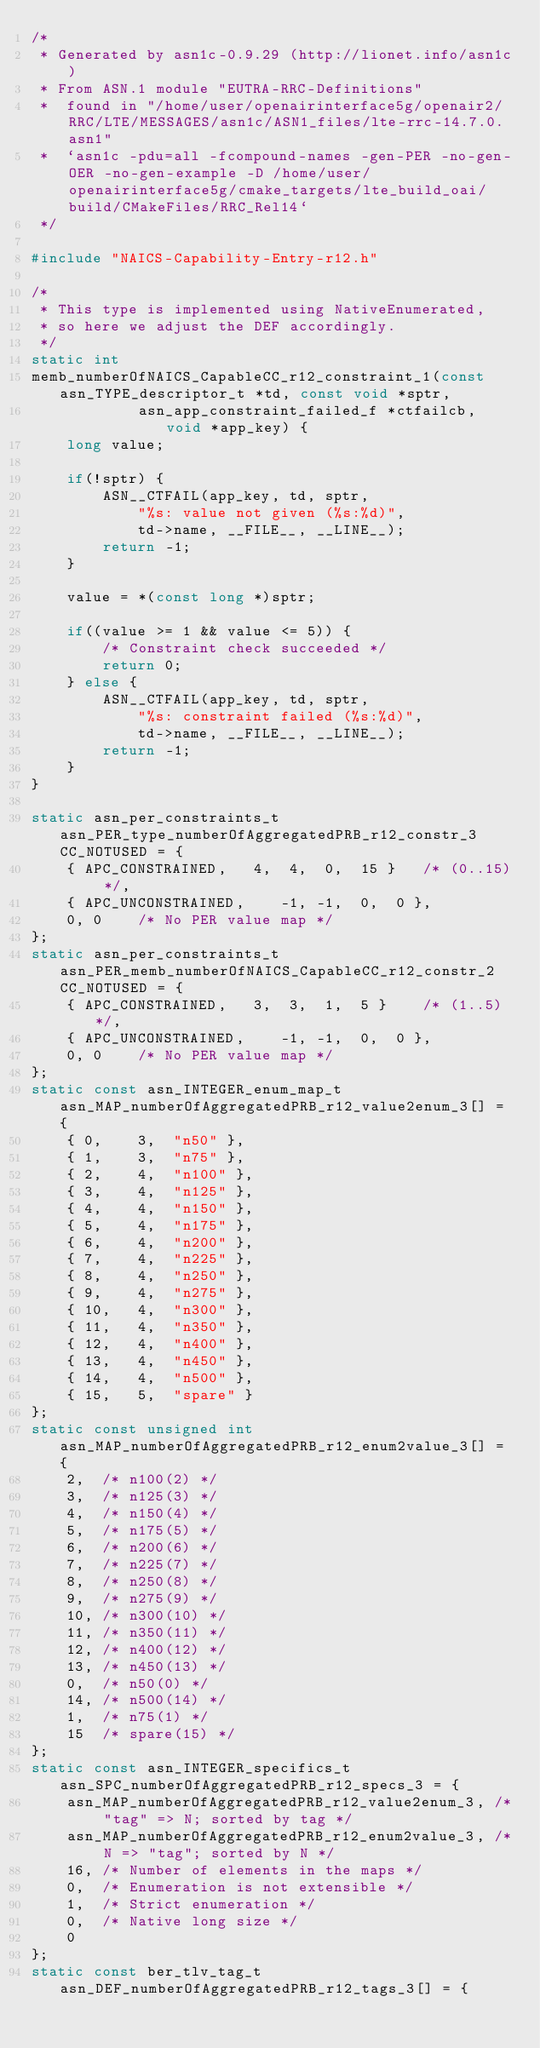<code> <loc_0><loc_0><loc_500><loc_500><_C_>/*
 * Generated by asn1c-0.9.29 (http://lionet.info/asn1c)
 * From ASN.1 module "EUTRA-RRC-Definitions"
 * 	found in "/home/user/openairinterface5g/openair2/RRC/LTE/MESSAGES/asn1c/ASN1_files/lte-rrc-14.7.0.asn1"
 * 	`asn1c -pdu=all -fcompound-names -gen-PER -no-gen-OER -no-gen-example -D /home/user/openairinterface5g/cmake_targets/lte_build_oai/build/CMakeFiles/RRC_Rel14`
 */

#include "NAICS-Capability-Entry-r12.h"

/*
 * This type is implemented using NativeEnumerated,
 * so here we adjust the DEF accordingly.
 */
static int
memb_numberOfNAICS_CapableCC_r12_constraint_1(const asn_TYPE_descriptor_t *td, const void *sptr,
			asn_app_constraint_failed_f *ctfailcb, void *app_key) {
	long value;
	
	if(!sptr) {
		ASN__CTFAIL(app_key, td, sptr,
			"%s: value not given (%s:%d)",
			td->name, __FILE__, __LINE__);
		return -1;
	}
	
	value = *(const long *)sptr;
	
	if((value >= 1 && value <= 5)) {
		/* Constraint check succeeded */
		return 0;
	} else {
		ASN__CTFAIL(app_key, td, sptr,
			"%s: constraint failed (%s:%d)",
			td->name, __FILE__, __LINE__);
		return -1;
	}
}

static asn_per_constraints_t asn_PER_type_numberOfAggregatedPRB_r12_constr_3 CC_NOTUSED = {
	{ APC_CONSTRAINED,	 4,  4,  0,  15 }	/* (0..15) */,
	{ APC_UNCONSTRAINED,	-1, -1,  0,  0 },
	0, 0	/* No PER value map */
};
static asn_per_constraints_t asn_PER_memb_numberOfNAICS_CapableCC_r12_constr_2 CC_NOTUSED = {
	{ APC_CONSTRAINED,	 3,  3,  1,  5 }	/* (1..5) */,
	{ APC_UNCONSTRAINED,	-1, -1,  0,  0 },
	0, 0	/* No PER value map */
};
static const asn_INTEGER_enum_map_t asn_MAP_numberOfAggregatedPRB_r12_value2enum_3[] = {
	{ 0,	3,	"n50" },
	{ 1,	3,	"n75" },
	{ 2,	4,	"n100" },
	{ 3,	4,	"n125" },
	{ 4,	4,	"n150" },
	{ 5,	4,	"n175" },
	{ 6,	4,	"n200" },
	{ 7,	4,	"n225" },
	{ 8,	4,	"n250" },
	{ 9,	4,	"n275" },
	{ 10,	4,	"n300" },
	{ 11,	4,	"n350" },
	{ 12,	4,	"n400" },
	{ 13,	4,	"n450" },
	{ 14,	4,	"n500" },
	{ 15,	5,	"spare" }
};
static const unsigned int asn_MAP_numberOfAggregatedPRB_r12_enum2value_3[] = {
	2,	/* n100(2) */
	3,	/* n125(3) */
	4,	/* n150(4) */
	5,	/* n175(5) */
	6,	/* n200(6) */
	7,	/* n225(7) */
	8,	/* n250(8) */
	9,	/* n275(9) */
	10,	/* n300(10) */
	11,	/* n350(11) */
	12,	/* n400(12) */
	13,	/* n450(13) */
	0,	/* n50(0) */
	14,	/* n500(14) */
	1,	/* n75(1) */
	15	/* spare(15) */
};
static const asn_INTEGER_specifics_t asn_SPC_numberOfAggregatedPRB_r12_specs_3 = {
	asn_MAP_numberOfAggregatedPRB_r12_value2enum_3,	/* "tag" => N; sorted by tag */
	asn_MAP_numberOfAggregatedPRB_r12_enum2value_3,	/* N => "tag"; sorted by N */
	16,	/* Number of elements in the maps */
	0,	/* Enumeration is not extensible */
	1,	/* Strict enumeration */
	0,	/* Native long size */
	0
};
static const ber_tlv_tag_t asn_DEF_numberOfAggregatedPRB_r12_tags_3[] = {</code> 